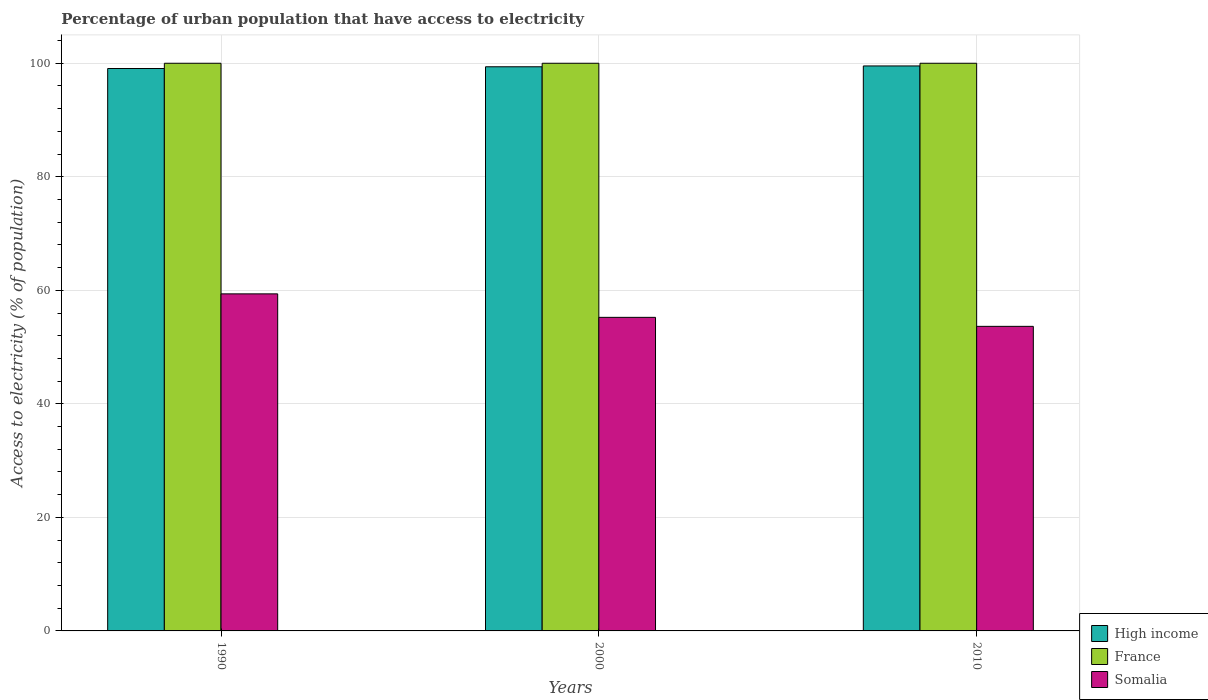Are the number of bars per tick equal to the number of legend labels?
Your answer should be very brief. Yes. Are the number of bars on each tick of the X-axis equal?
Offer a very short reply. Yes. How many bars are there on the 3rd tick from the left?
Your answer should be compact. 3. How many bars are there on the 2nd tick from the right?
Your answer should be very brief. 3. What is the label of the 1st group of bars from the left?
Ensure brevity in your answer.  1990. What is the percentage of urban population that have access to electricity in High income in 2000?
Provide a short and direct response. 99.38. Across all years, what is the maximum percentage of urban population that have access to electricity in High income?
Your answer should be compact. 99.53. Across all years, what is the minimum percentage of urban population that have access to electricity in Somalia?
Give a very brief answer. 53.65. In which year was the percentage of urban population that have access to electricity in Somalia maximum?
Keep it short and to the point. 1990. What is the total percentage of urban population that have access to electricity in High income in the graph?
Offer a terse response. 297.98. What is the difference between the percentage of urban population that have access to electricity in High income in 1990 and that in 2000?
Keep it short and to the point. -0.31. What is the difference between the percentage of urban population that have access to electricity in High income in 2000 and the percentage of urban population that have access to electricity in Somalia in 2010?
Your answer should be very brief. 45.73. What is the average percentage of urban population that have access to electricity in Somalia per year?
Give a very brief answer. 56.09. In the year 1990, what is the difference between the percentage of urban population that have access to electricity in France and percentage of urban population that have access to electricity in High income?
Your answer should be compact. 0.93. What is the ratio of the percentage of urban population that have access to electricity in Somalia in 2000 to that in 2010?
Ensure brevity in your answer.  1.03. Is the difference between the percentage of urban population that have access to electricity in France in 1990 and 2010 greater than the difference between the percentage of urban population that have access to electricity in High income in 1990 and 2010?
Provide a short and direct response. Yes. What is the difference between the highest and the second highest percentage of urban population that have access to electricity in France?
Ensure brevity in your answer.  0. Is the sum of the percentage of urban population that have access to electricity in High income in 1990 and 2000 greater than the maximum percentage of urban population that have access to electricity in Somalia across all years?
Your answer should be compact. Yes. What does the 3rd bar from the left in 2010 represents?
Provide a short and direct response. Somalia. What does the 1st bar from the right in 1990 represents?
Provide a short and direct response. Somalia. Are all the bars in the graph horizontal?
Offer a terse response. No. How many years are there in the graph?
Make the answer very short. 3. What is the difference between two consecutive major ticks on the Y-axis?
Your answer should be compact. 20. Where does the legend appear in the graph?
Your response must be concise. Bottom right. How many legend labels are there?
Give a very brief answer. 3. What is the title of the graph?
Provide a short and direct response. Percentage of urban population that have access to electricity. Does "Panama" appear as one of the legend labels in the graph?
Your answer should be very brief. No. What is the label or title of the Y-axis?
Offer a terse response. Access to electricity (% of population). What is the Access to electricity (% of population) in High income in 1990?
Provide a short and direct response. 99.07. What is the Access to electricity (% of population) of France in 1990?
Offer a terse response. 100. What is the Access to electricity (% of population) in Somalia in 1990?
Ensure brevity in your answer.  59.38. What is the Access to electricity (% of population) of High income in 2000?
Your response must be concise. 99.38. What is the Access to electricity (% of population) in Somalia in 2000?
Make the answer very short. 55.24. What is the Access to electricity (% of population) in High income in 2010?
Keep it short and to the point. 99.53. What is the Access to electricity (% of population) in Somalia in 2010?
Provide a succinct answer. 53.65. Across all years, what is the maximum Access to electricity (% of population) in High income?
Ensure brevity in your answer.  99.53. Across all years, what is the maximum Access to electricity (% of population) of Somalia?
Give a very brief answer. 59.38. Across all years, what is the minimum Access to electricity (% of population) in High income?
Your answer should be compact. 99.07. Across all years, what is the minimum Access to electricity (% of population) in Somalia?
Give a very brief answer. 53.65. What is the total Access to electricity (% of population) in High income in the graph?
Make the answer very short. 297.98. What is the total Access to electricity (% of population) of France in the graph?
Make the answer very short. 300. What is the total Access to electricity (% of population) in Somalia in the graph?
Your answer should be compact. 168.27. What is the difference between the Access to electricity (% of population) of High income in 1990 and that in 2000?
Your answer should be compact. -0.31. What is the difference between the Access to electricity (% of population) of France in 1990 and that in 2000?
Give a very brief answer. 0. What is the difference between the Access to electricity (% of population) of Somalia in 1990 and that in 2000?
Make the answer very short. 4.14. What is the difference between the Access to electricity (% of population) of High income in 1990 and that in 2010?
Give a very brief answer. -0.45. What is the difference between the Access to electricity (% of population) in Somalia in 1990 and that in 2010?
Offer a very short reply. 5.72. What is the difference between the Access to electricity (% of population) in High income in 2000 and that in 2010?
Make the answer very short. -0.14. What is the difference between the Access to electricity (% of population) in Somalia in 2000 and that in 2010?
Your response must be concise. 1.58. What is the difference between the Access to electricity (% of population) of High income in 1990 and the Access to electricity (% of population) of France in 2000?
Your response must be concise. -0.93. What is the difference between the Access to electricity (% of population) of High income in 1990 and the Access to electricity (% of population) of Somalia in 2000?
Your answer should be compact. 43.84. What is the difference between the Access to electricity (% of population) of France in 1990 and the Access to electricity (% of population) of Somalia in 2000?
Offer a terse response. 44.76. What is the difference between the Access to electricity (% of population) in High income in 1990 and the Access to electricity (% of population) in France in 2010?
Offer a very short reply. -0.93. What is the difference between the Access to electricity (% of population) of High income in 1990 and the Access to electricity (% of population) of Somalia in 2010?
Provide a short and direct response. 45.42. What is the difference between the Access to electricity (% of population) of France in 1990 and the Access to electricity (% of population) of Somalia in 2010?
Provide a succinct answer. 46.35. What is the difference between the Access to electricity (% of population) in High income in 2000 and the Access to electricity (% of population) in France in 2010?
Offer a very short reply. -0.62. What is the difference between the Access to electricity (% of population) of High income in 2000 and the Access to electricity (% of population) of Somalia in 2010?
Your response must be concise. 45.73. What is the difference between the Access to electricity (% of population) of France in 2000 and the Access to electricity (% of population) of Somalia in 2010?
Make the answer very short. 46.35. What is the average Access to electricity (% of population) in High income per year?
Your answer should be very brief. 99.33. What is the average Access to electricity (% of population) of Somalia per year?
Your response must be concise. 56.09. In the year 1990, what is the difference between the Access to electricity (% of population) in High income and Access to electricity (% of population) in France?
Offer a terse response. -0.93. In the year 1990, what is the difference between the Access to electricity (% of population) in High income and Access to electricity (% of population) in Somalia?
Provide a short and direct response. 39.7. In the year 1990, what is the difference between the Access to electricity (% of population) in France and Access to electricity (% of population) in Somalia?
Offer a terse response. 40.62. In the year 2000, what is the difference between the Access to electricity (% of population) in High income and Access to electricity (% of population) in France?
Keep it short and to the point. -0.62. In the year 2000, what is the difference between the Access to electricity (% of population) in High income and Access to electricity (% of population) in Somalia?
Your answer should be very brief. 44.14. In the year 2000, what is the difference between the Access to electricity (% of population) in France and Access to electricity (% of population) in Somalia?
Your answer should be very brief. 44.76. In the year 2010, what is the difference between the Access to electricity (% of population) in High income and Access to electricity (% of population) in France?
Your answer should be compact. -0.47. In the year 2010, what is the difference between the Access to electricity (% of population) in High income and Access to electricity (% of population) in Somalia?
Your answer should be very brief. 45.87. In the year 2010, what is the difference between the Access to electricity (% of population) of France and Access to electricity (% of population) of Somalia?
Ensure brevity in your answer.  46.35. What is the ratio of the Access to electricity (% of population) in High income in 1990 to that in 2000?
Your answer should be compact. 1. What is the ratio of the Access to electricity (% of population) of France in 1990 to that in 2000?
Keep it short and to the point. 1. What is the ratio of the Access to electricity (% of population) in Somalia in 1990 to that in 2000?
Your response must be concise. 1.07. What is the ratio of the Access to electricity (% of population) in France in 1990 to that in 2010?
Keep it short and to the point. 1. What is the ratio of the Access to electricity (% of population) in Somalia in 1990 to that in 2010?
Keep it short and to the point. 1.11. What is the ratio of the Access to electricity (% of population) of France in 2000 to that in 2010?
Make the answer very short. 1. What is the ratio of the Access to electricity (% of population) of Somalia in 2000 to that in 2010?
Offer a terse response. 1.03. What is the difference between the highest and the second highest Access to electricity (% of population) in High income?
Your answer should be very brief. 0.14. What is the difference between the highest and the second highest Access to electricity (% of population) in Somalia?
Provide a succinct answer. 4.14. What is the difference between the highest and the lowest Access to electricity (% of population) of High income?
Your response must be concise. 0.45. What is the difference between the highest and the lowest Access to electricity (% of population) in France?
Offer a very short reply. 0. What is the difference between the highest and the lowest Access to electricity (% of population) of Somalia?
Offer a terse response. 5.72. 